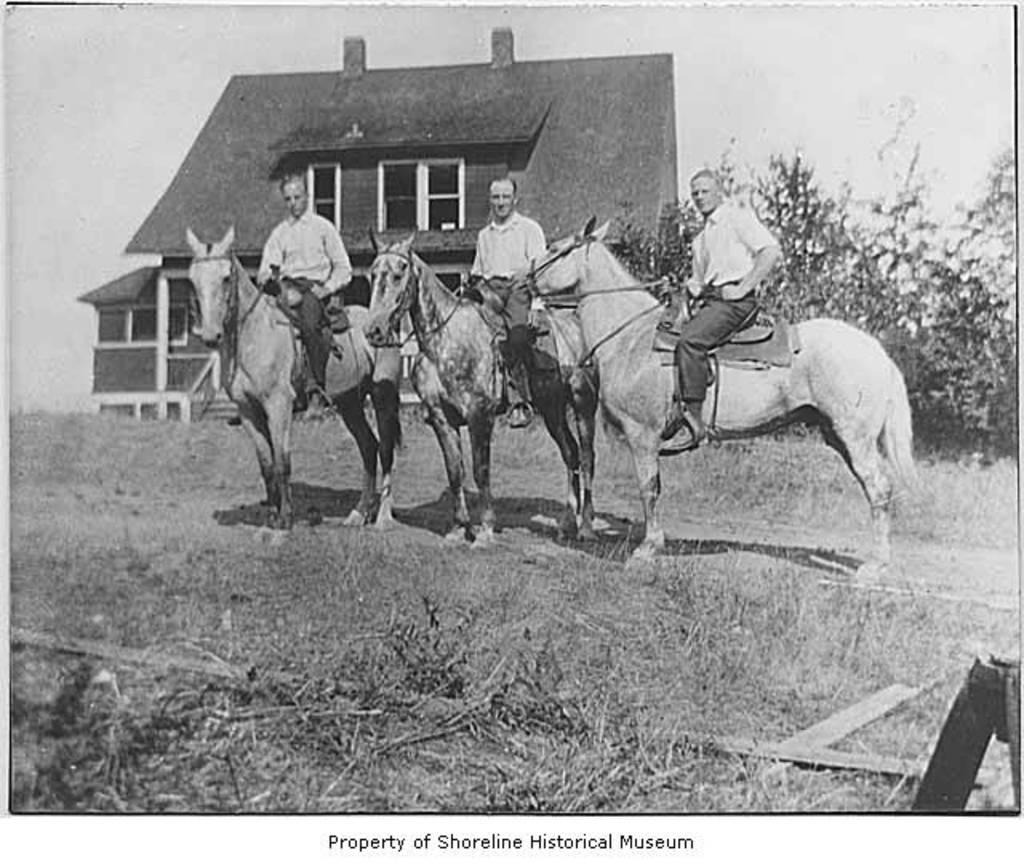What is the color scheme of the image? The image is black and white. How many people are in the image? There are three persons in the image. What are the persons doing in the image? The persons are sitting on a horse. What can be seen in the background of the image? There is a building in the background of the image. What type of terrain is visible at the bottom of the image? There is grassy land at the bottom of the image. What type of pie is being served at the gathering in the image? There is no gathering or pie in the image; it features three persons sitting on a horse with a background of a building and grassy land. 